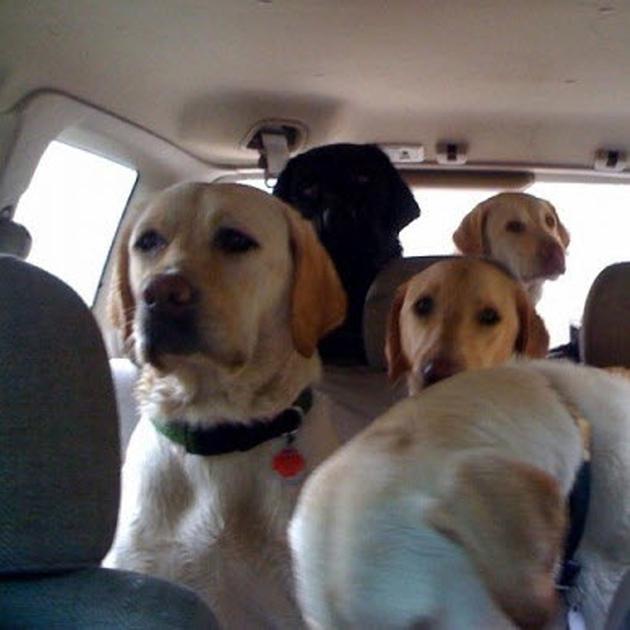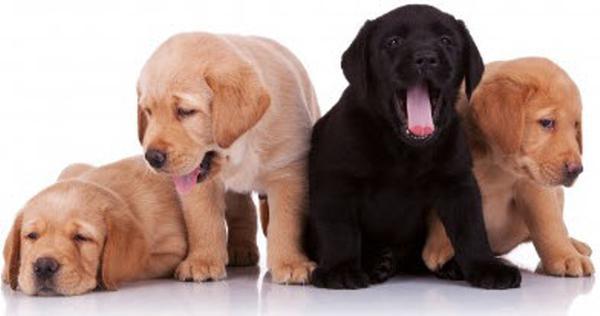The first image is the image on the left, the second image is the image on the right. For the images shown, is this caption "There are no more than five dogs" true? Answer yes or no. No. 